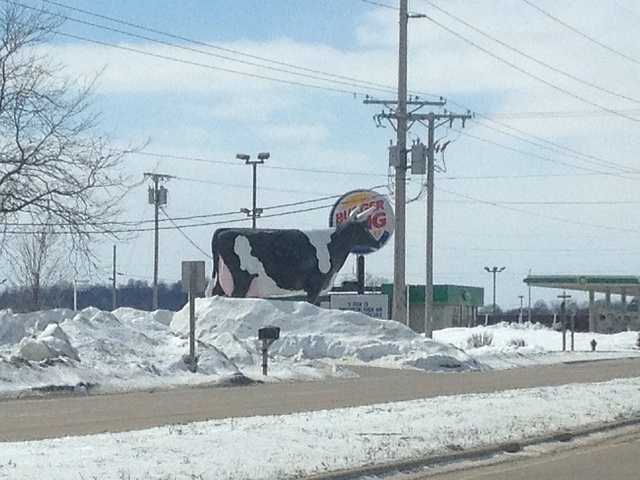Describe the objects in this image and their specific colors. I can see cow in lightblue, darkblue, darkgray, black, and gray tones and fire hydrant in lightblue, purple, darkgray, lightgray, and gray tones in this image. 